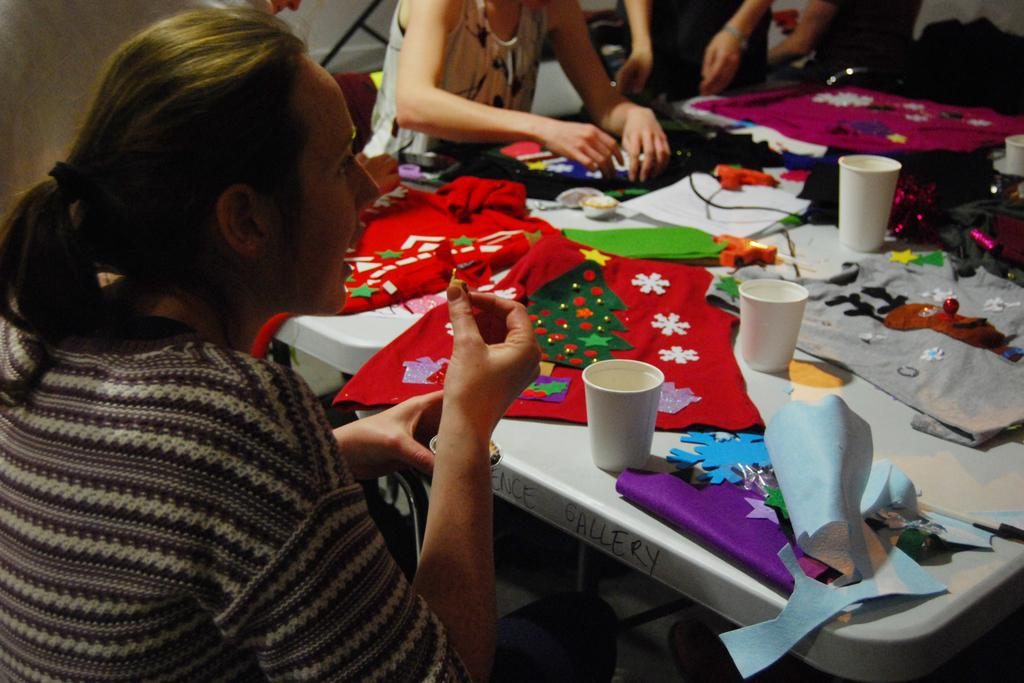What are the people in the image doing? The people in the image are sitting on chairs. What is in front of the chairs? There is a table in front of the chairs. What items can be seen on the table? Clothes, glasses, and stitching materials are on the table. What does the stone taste like in the image? There is no stone present in the image, so it is not possible to determine its taste. 